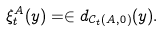<formula> <loc_0><loc_0><loc_500><loc_500>\xi _ { t } ^ { A } ( y ) = \in d _ { \mathcal { C } _ { t } ( A , 0 ) } ( y ) .</formula> 